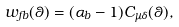<formula> <loc_0><loc_0><loc_500><loc_500>w _ { f b } ( \theta ) = ( { \alpha } _ { b } - 1 ) C _ { \mu \delta } ( \theta ) ,</formula> 